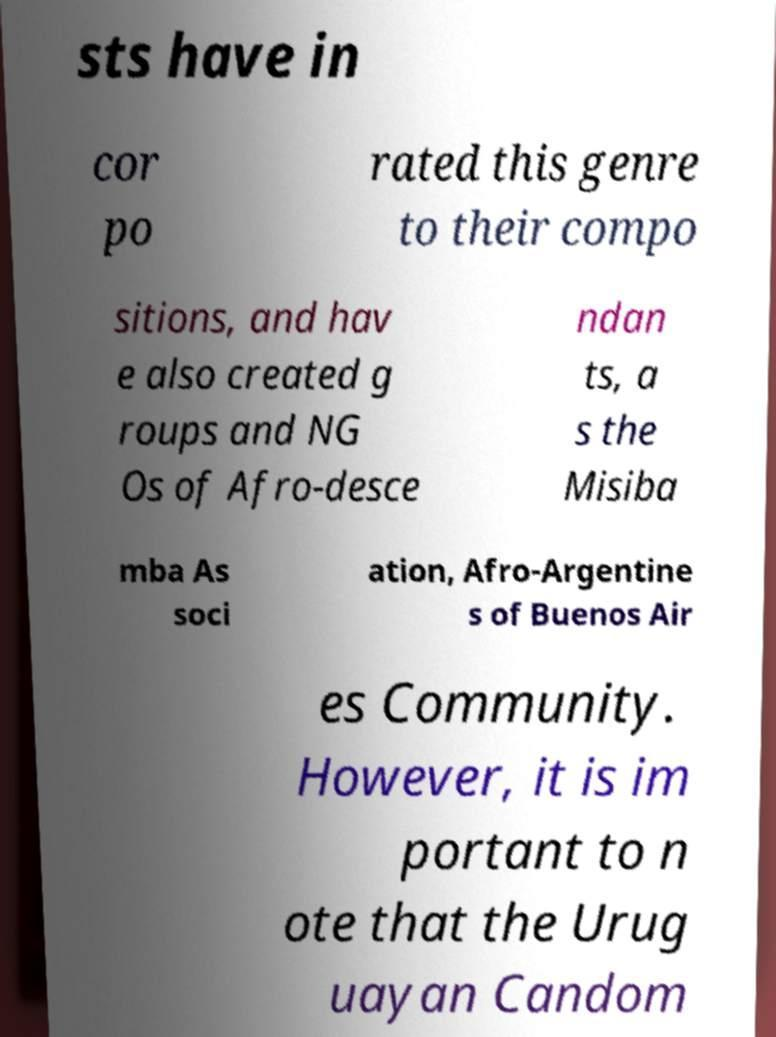Please identify and transcribe the text found in this image. sts have in cor po rated this genre to their compo sitions, and hav e also created g roups and NG Os of Afro-desce ndan ts, a s the Misiba mba As soci ation, Afro-Argentine s of Buenos Air es Community. However, it is im portant to n ote that the Urug uayan Candom 